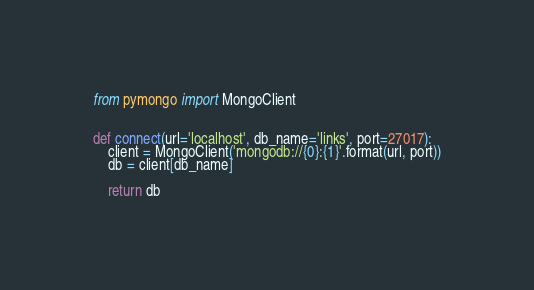Convert code to text. <code><loc_0><loc_0><loc_500><loc_500><_Python_>from pymongo import MongoClient


def connect(url='localhost', db_name='links', port=27017):
    client = MongoClient('mongodb://{0}:{1}'.format(url, port))
    db = client[db_name]

    return db
</code> 